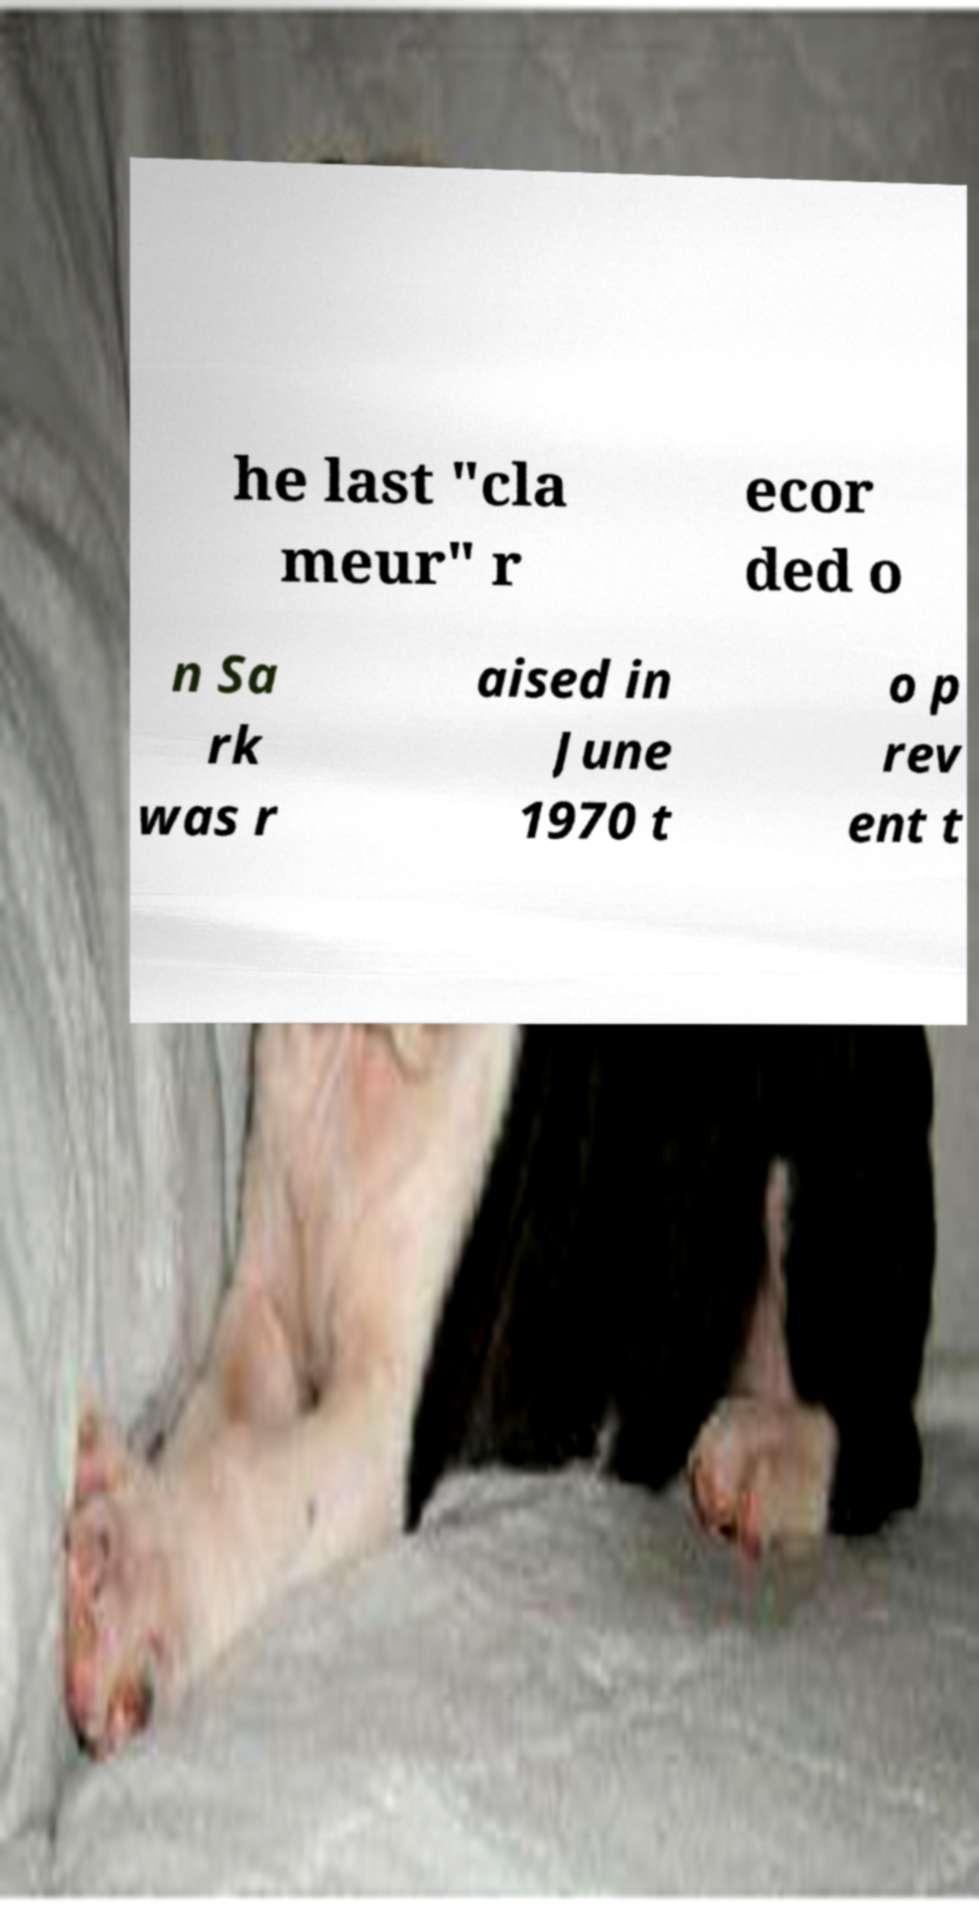Can you accurately transcribe the text from the provided image for me? he last "cla meur" r ecor ded o n Sa rk was r aised in June 1970 t o p rev ent t 